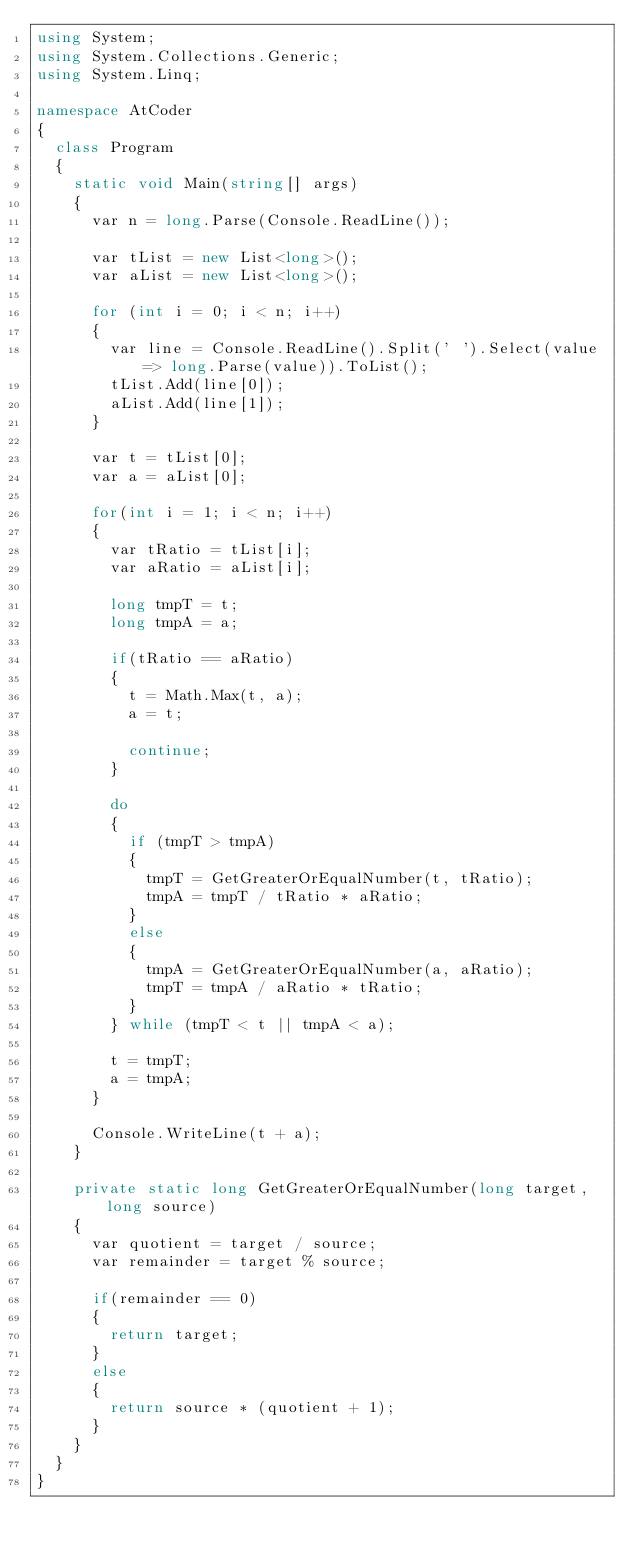<code> <loc_0><loc_0><loc_500><loc_500><_C#_>using System;
using System.Collections.Generic;
using System.Linq;

namespace AtCoder
{
	class Program
	{
		static void Main(string[] args)
		{
			var n = long.Parse(Console.ReadLine());

			var tList = new List<long>();
			var aList = new List<long>();

			for (int i = 0; i < n; i++)
			{
				var line = Console.ReadLine().Split(' ').Select(value => long.Parse(value)).ToList();
				tList.Add(line[0]);
				aList.Add(line[1]);
			}

			var t = tList[0];
			var a = aList[0];

			for(int i = 1; i < n; i++)
			{
				var tRatio = tList[i];
				var aRatio = aList[i];

				long tmpT = t;
				long tmpA = a;

				if(tRatio == aRatio)
				{
					t = Math.Max(t, a);
					a = t;

					continue;
				}

				do
				{
					if (tmpT > tmpA)
					{
						tmpT = GetGreaterOrEqualNumber(t, tRatio);
						tmpA = tmpT / tRatio * aRatio;
					}
					else
					{
						tmpA = GetGreaterOrEqualNumber(a, aRatio);
						tmpT = tmpA / aRatio * tRatio;
					}
				} while (tmpT < t || tmpA < a);

				t = tmpT;
				a = tmpA;
			}
			
			Console.WriteLine(t + a);
		}

		private static long GetGreaterOrEqualNumber(long target, long source)
		{
			var quotient = target / source;
			var remainder = target % source;

			if(remainder == 0)
			{
				return target;
			}
			else
			{
				return source * (quotient + 1);
			}
		}
	}
}
</code> 